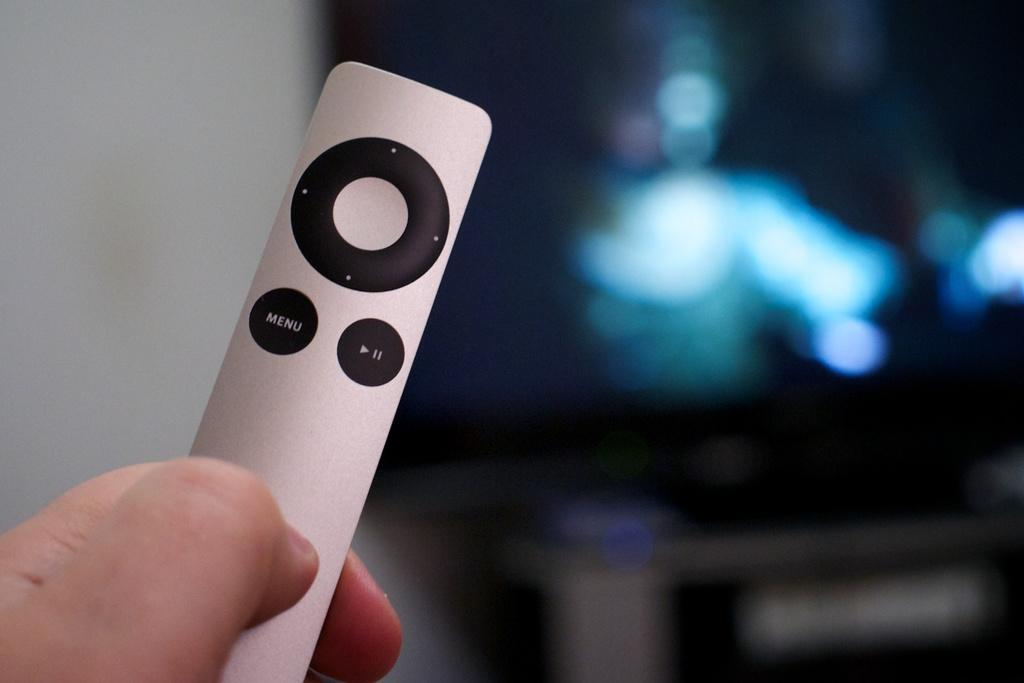Provide a one-sentence caption for the provided image. A small silver remote features a Menu button. 